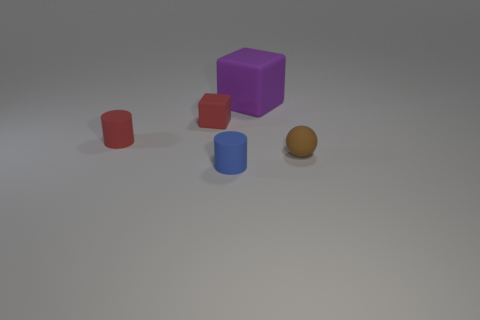Add 3 tiny green metallic things. How many objects exist? 8 Subtract all blue cylinders. How many cylinders are left? 1 Subtract all cubes. How many objects are left? 3 Add 1 matte objects. How many matte objects exist? 6 Subtract 1 purple cubes. How many objects are left? 4 Subtract all big gray metallic balls. Subtract all blue matte cylinders. How many objects are left? 4 Add 2 big purple objects. How many big purple objects are left? 3 